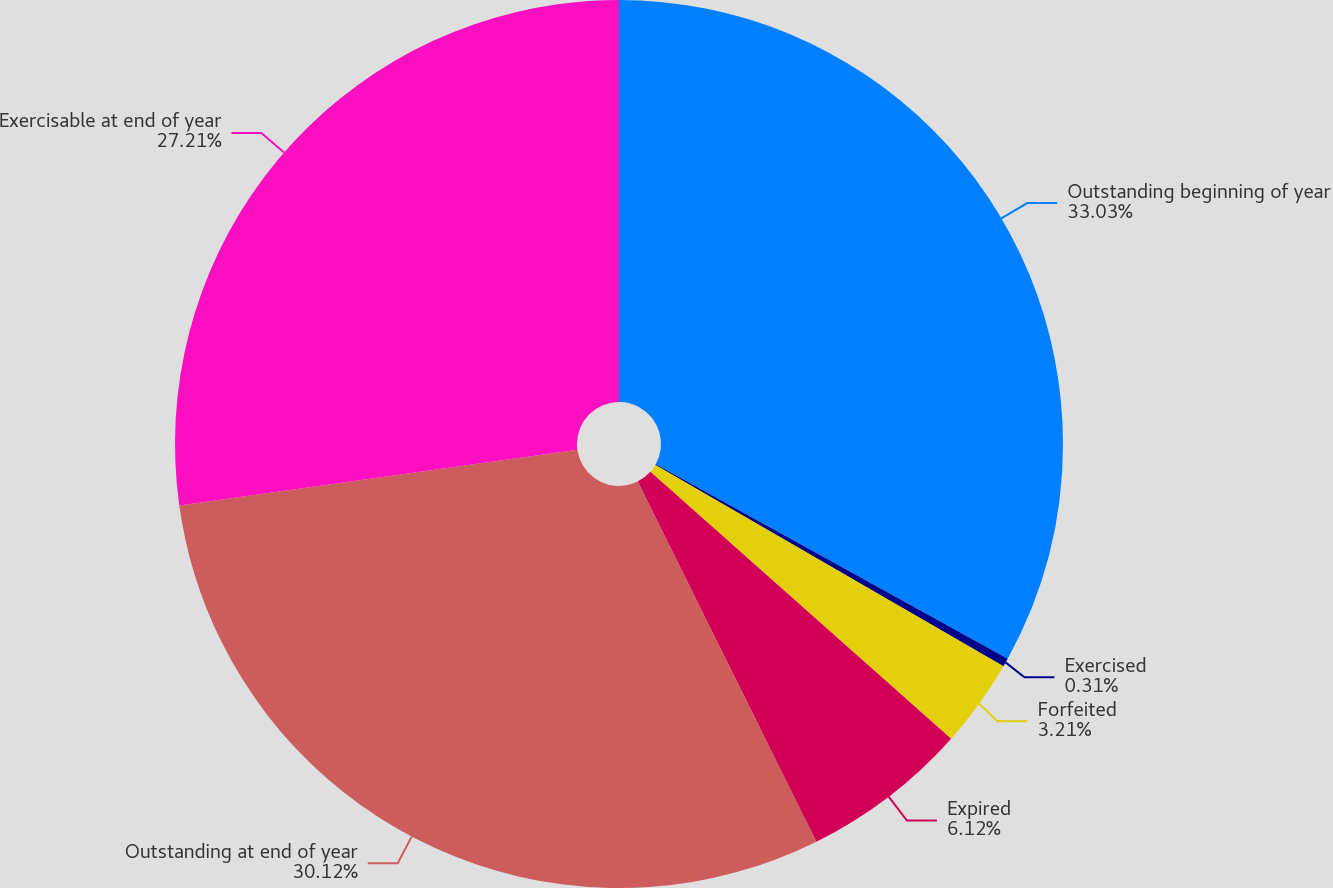Convert chart. <chart><loc_0><loc_0><loc_500><loc_500><pie_chart><fcel>Outstanding beginning of year<fcel>Exercised<fcel>Forfeited<fcel>Expired<fcel>Outstanding at end of year<fcel>Exercisable at end of year<nl><fcel>33.03%<fcel>0.31%<fcel>3.21%<fcel>6.12%<fcel>30.12%<fcel>27.21%<nl></chart> 